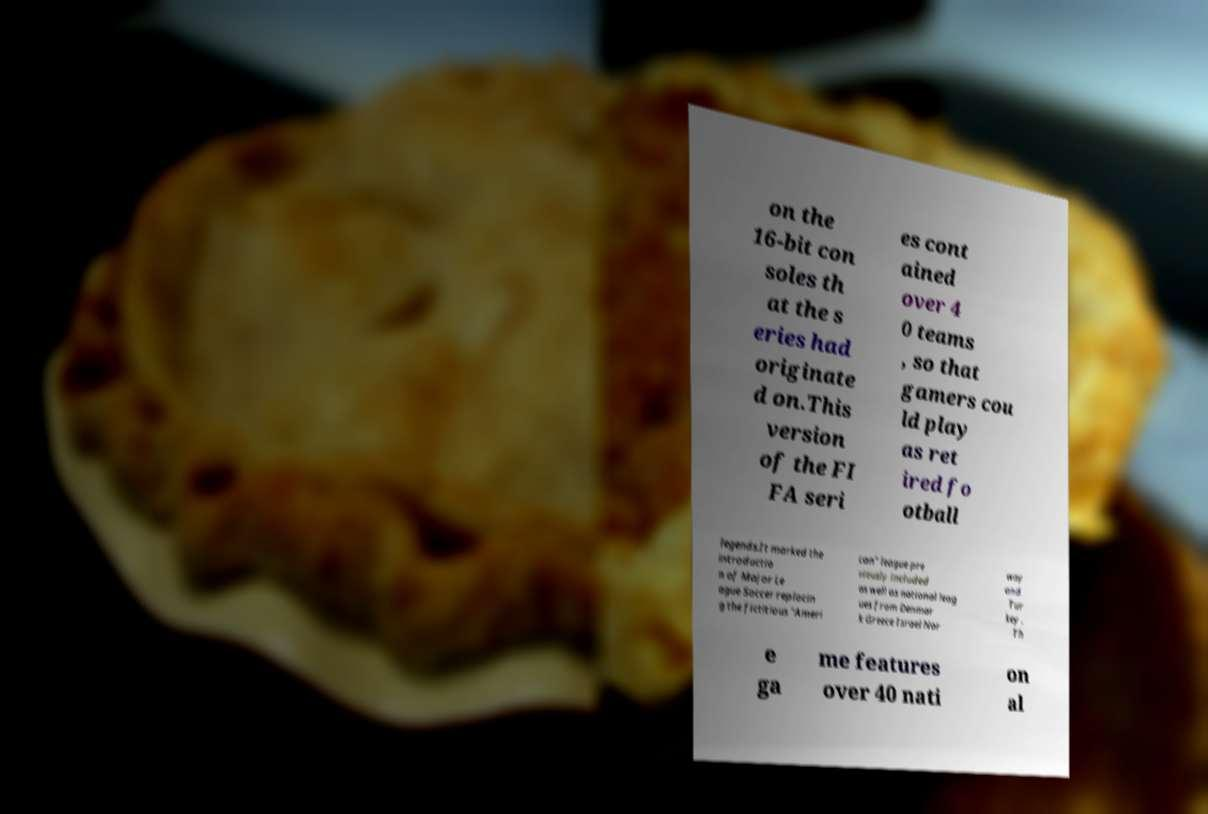I need the written content from this picture converted into text. Can you do that? on the 16-bit con soles th at the s eries had originate d on.This version of the FI FA seri es cont ained over 4 0 teams , so that gamers cou ld play as ret ired fo otball legends.It marked the introductio n of Major Le ague Soccer replacin g the fictitious "Ameri can" league pre viously included as well as national leag ues from Denmar k Greece Israel Nor way and Tur key . Th e ga me features over 40 nati on al 